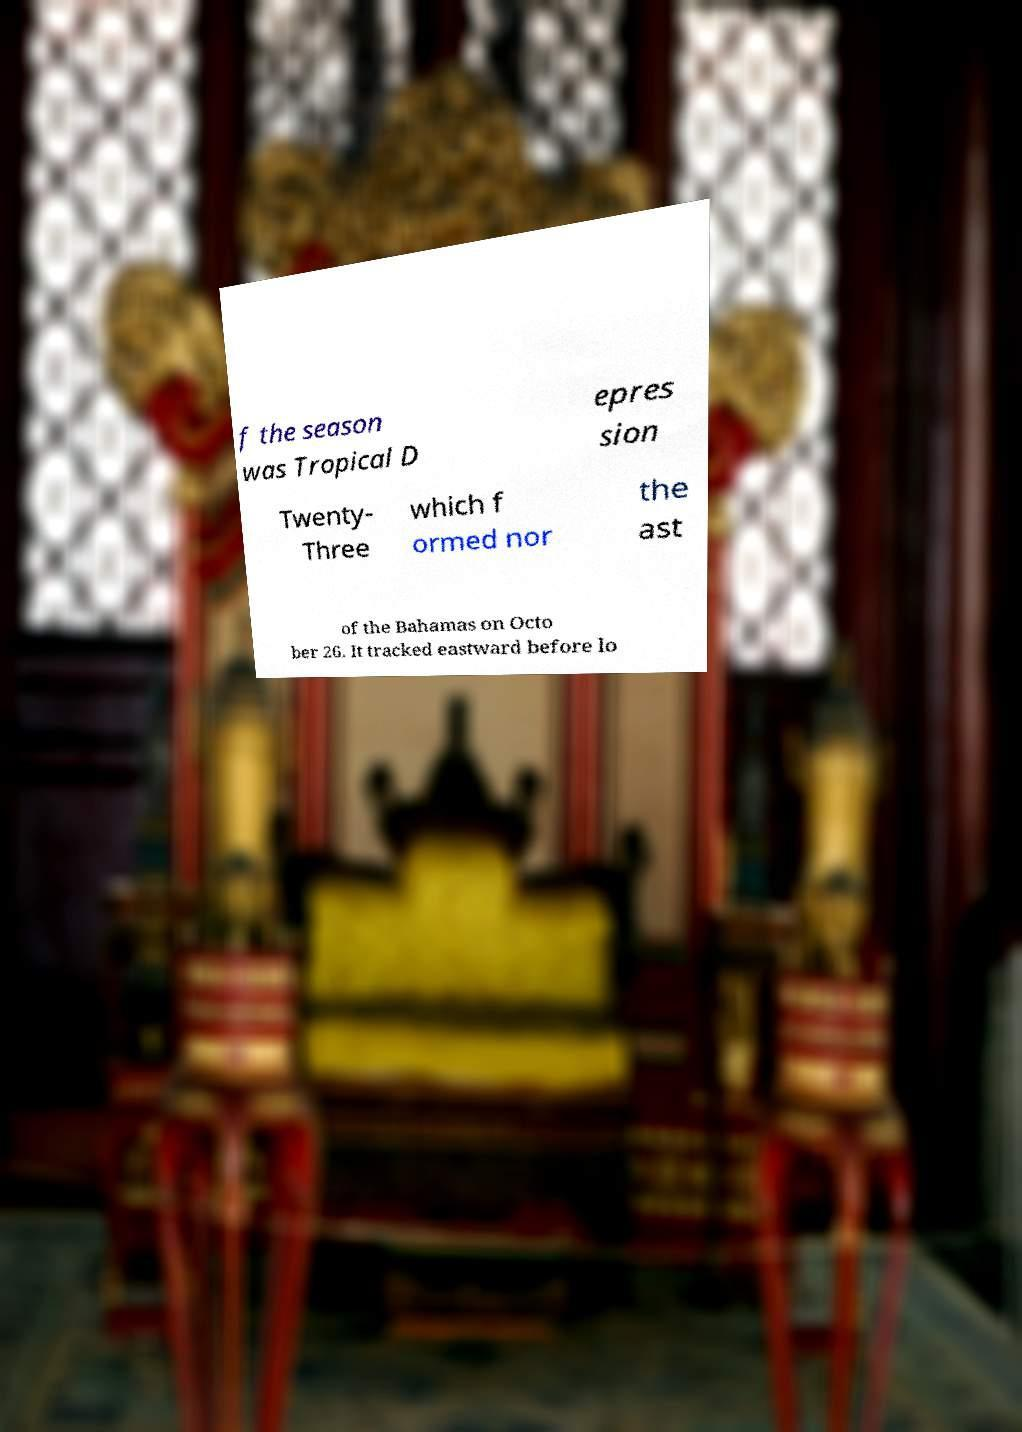Could you assist in decoding the text presented in this image and type it out clearly? f the season was Tropical D epres sion Twenty- Three which f ormed nor the ast of the Bahamas on Octo ber 26. It tracked eastward before lo 